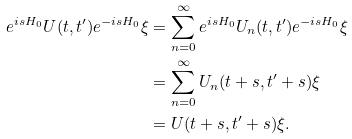<formula> <loc_0><loc_0><loc_500><loc_500>e ^ { i s H _ { 0 } } U ( t , t ^ { \prime } ) e ^ { - i s H _ { 0 } } \xi & = \sum _ { n = 0 } ^ { \infty } e ^ { i s H _ { 0 } } U _ { n } ( t , t ^ { \prime } ) e ^ { - i s H _ { 0 } } \xi \\ & = \sum _ { n = 0 } ^ { \infty } U _ { n } ( t + s , t ^ { \prime } + s ) \xi \\ & = U ( t + s , t ^ { \prime } + s ) \xi .</formula> 